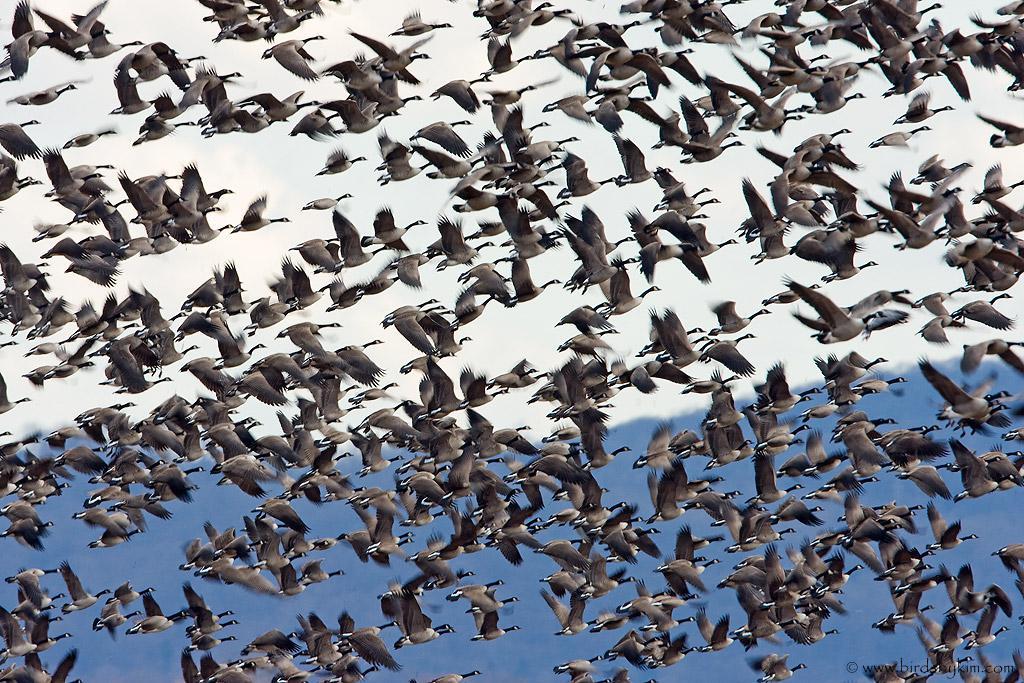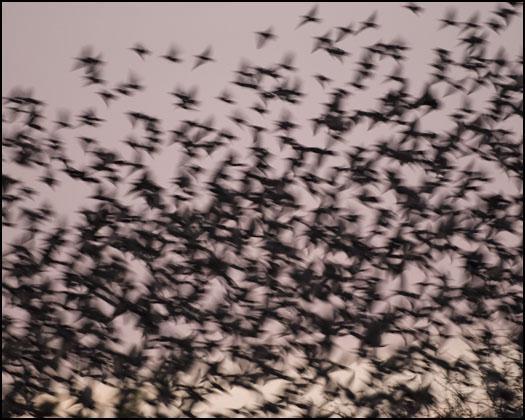The first image is the image on the left, the second image is the image on the right. Given the left and right images, does the statement "Flocks of birds fly over water in at least one image." hold true? Answer yes or no. No. 